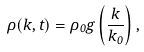<formula> <loc_0><loc_0><loc_500><loc_500>\rho ( k , t ) = \rho _ { 0 } g \left ( \frac { k } { k _ { 0 } } \right ) ,</formula> 